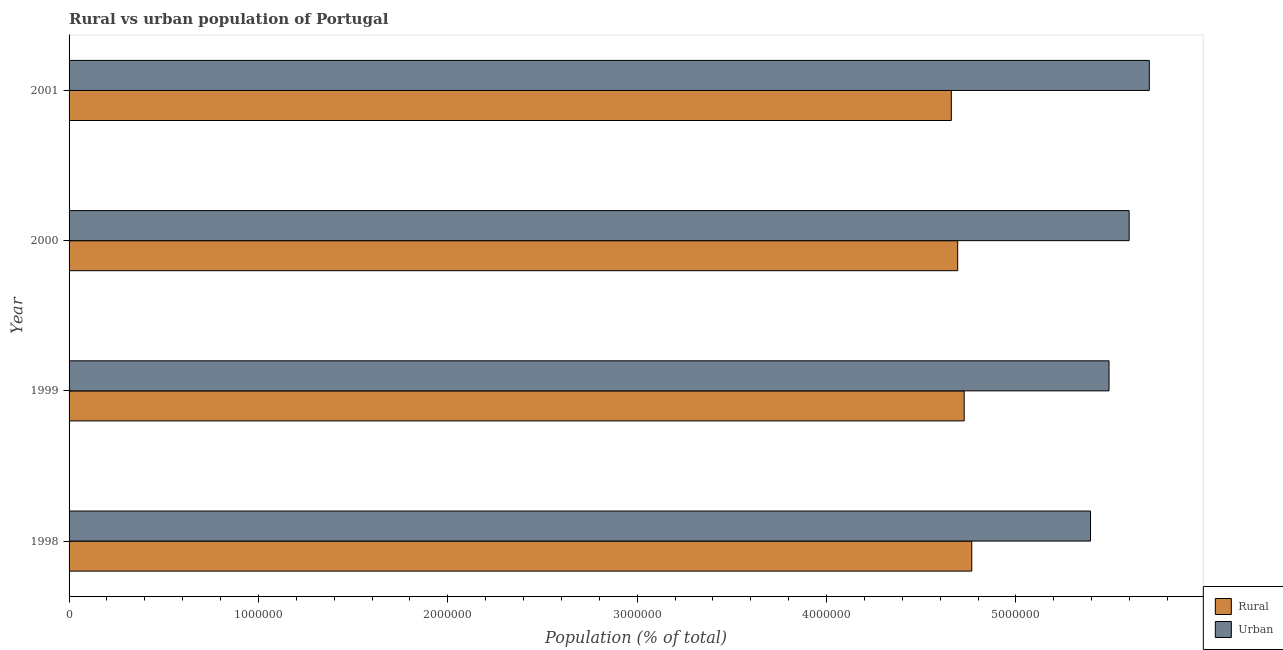How many different coloured bars are there?
Offer a terse response. 2. Are the number of bars per tick equal to the number of legend labels?
Provide a succinct answer. Yes. What is the urban population density in 1998?
Offer a very short reply. 5.39e+06. Across all years, what is the maximum rural population density?
Ensure brevity in your answer.  4.77e+06. Across all years, what is the minimum rural population density?
Provide a succinct answer. 4.66e+06. In which year was the urban population density maximum?
Make the answer very short. 2001. What is the total rural population density in the graph?
Give a very brief answer. 1.88e+07. What is the difference between the rural population density in 1999 and that in 2000?
Your response must be concise. 3.42e+04. What is the difference between the rural population density in 1998 and the urban population density in 2000?
Provide a short and direct response. -8.31e+05. What is the average rural population density per year?
Offer a very short reply. 4.71e+06. In the year 1999, what is the difference between the rural population density and urban population density?
Make the answer very short. -7.65e+05. What is the ratio of the urban population density in 2000 to that in 2001?
Provide a succinct answer. 0.98. What is the difference between the highest and the second highest rural population density?
Give a very brief answer. 4.01e+04. What is the difference between the highest and the lowest urban population density?
Your answer should be compact. 3.10e+05. In how many years, is the urban population density greater than the average urban population density taken over all years?
Your answer should be compact. 2. Is the sum of the rural population density in 2000 and 2001 greater than the maximum urban population density across all years?
Provide a succinct answer. Yes. What does the 1st bar from the top in 1998 represents?
Ensure brevity in your answer.  Urban. What does the 2nd bar from the bottom in 2000 represents?
Give a very brief answer. Urban. How many bars are there?
Make the answer very short. 8. What is the difference between two consecutive major ticks on the X-axis?
Ensure brevity in your answer.  1.00e+06. Are the values on the major ticks of X-axis written in scientific E-notation?
Make the answer very short. No. Does the graph contain any zero values?
Make the answer very short. No. Where does the legend appear in the graph?
Provide a short and direct response. Bottom right. What is the title of the graph?
Your response must be concise. Rural vs urban population of Portugal. Does "Formally registered" appear as one of the legend labels in the graph?
Keep it short and to the point. No. What is the label or title of the X-axis?
Provide a succinct answer. Population (% of total). What is the Population (% of total) in Rural in 1998?
Provide a succinct answer. 4.77e+06. What is the Population (% of total) in Urban in 1998?
Give a very brief answer. 5.39e+06. What is the Population (% of total) of Rural in 1999?
Make the answer very short. 4.73e+06. What is the Population (% of total) of Urban in 1999?
Ensure brevity in your answer.  5.49e+06. What is the Population (% of total) of Rural in 2000?
Provide a short and direct response. 4.69e+06. What is the Population (% of total) of Urban in 2000?
Your answer should be compact. 5.60e+06. What is the Population (% of total) of Rural in 2001?
Your response must be concise. 4.66e+06. What is the Population (% of total) in Urban in 2001?
Your answer should be compact. 5.70e+06. Across all years, what is the maximum Population (% of total) in Rural?
Your response must be concise. 4.77e+06. Across all years, what is the maximum Population (% of total) of Urban?
Your answer should be compact. 5.70e+06. Across all years, what is the minimum Population (% of total) in Rural?
Offer a terse response. 4.66e+06. Across all years, what is the minimum Population (% of total) in Urban?
Your response must be concise. 5.39e+06. What is the total Population (% of total) in Rural in the graph?
Give a very brief answer. 1.88e+07. What is the total Population (% of total) of Urban in the graph?
Offer a terse response. 2.22e+07. What is the difference between the Population (% of total) in Rural in 1998 and that in 1999?
Your answer should be very brief. 4.01e+04. What is the difference between the Population (% of total) in Urban in 1998 and that in 1999?
Provide a short and direct response. -9.77e+04. What is the difference between the Population (% of total) in Rural in 1998 and that in 2000?
Ensure brevity in your answer.  7.43e+04. What is the difference between the Population (% of total) in Urban in 1998 and that in 2000?
Your answer should be compact. -2.04e+05. What is the difference between the Population (% of total) in Rural in 1998 and that in 2001?
Ensure brevity in your answer.  1.08e+05. What is the difference between the Population (% of total) in Urban in 1998 and that in 2001?
Give a very brief answer. -3.10e+05. What is the difference between the Population (% of total) in Rural in 1999 and that in 2000?
Your response must be concise. 3.42e+04. What is the difference between the Population (% of total) in Urban in 1999 and that in 2000?
Provide a short and direct response. -1.06e+05. What is the difference between the Population (% of total) in Rural in 1999 and that in 2001?
Provide a succinct answer. 6.78e+04. What is the difference between the Population (% of total) of Urban in 1999 and that in 2001?
Ensure brevity in your answer.  -2.13e+05. What is the difference between the Population (% of total) in Rural in 2000 and that in 2001?
Offer a very short reply. 3.36e+04. What is the difference between the Population (% of total) of Urban in 2000 and that in 2001?
Offer a very short reply. -1.06e+05. What is the difference between the Population (% of total) in Rural in 1998 and the Population (% of total) in Urban in 1999?
Your answer should be compact. -7.25e+05. What is the difference between the Population (% of total) of Rural in 1998 and the Population (% of total) of Urban in 2000?
Provide a short and direct response. -8.31e+05. What is the difference between the Population (% of total) of Rural in 1998 and the Population (% of total) of Urban in 2001?
Offer a terse response. -9.38e+05. What is the difference between the Population (% of total) in Rural in 1999 and the Population (% of total) in Urban in 2000?
Keep it short and to the point. -8.71e+05. What is the difference between the Population (% of total) in Rural in 1999 and the Population (% of total) in Urban in 2001?
Your response must be concise. -9.78e+05. What is the difference between the Population (% of total) in Rural in 2000 and the Population (% of total) in Urban in 2001?
Make the answer very short. -1.01e+06. What is the average Population (% of total) of Rural per year?
Your answer should be compact. 4.71e+06. What is the average Population (% of total) in Urban per year?
Your answer should be very brief. 5.55e+06. In the year 1998, what is the difference between the Population (% of total) in Rural and Population (% of total) in Urban?
Give a very brief answer. -6.27e+05. In the year 1999, what is the difference between the Population (% of total) of Rural and Population (% of total) of Urban?
Ensure brevity in your answer.  -7.65e+05. In the year 2000, what is the difference between the Population (% of total) of Rural and Population (% of total) of Urban?
Your answer should be very brief. -9.05e+05. In the year 2001, what is the difference between the Population (% of total) of Rural and Population (% of total) of Urban?
Keep it short and to the point. -1.05e+06. What is the ratio of the Population (% of total) in Rural in 1998 to that in 1999?
Your answer should be very brief. 1.01. What is the ratio of the Population (% of total) of Urban in 1998 to that in 1999?
Offer a very short reply. 0.98. What is the ratio of the Population (% of total) of Rural in 1998 to that in 2000?
Your answer should be very brief. 1.02. What is the ratio of the Population (% of total) in Urban in 1998 to that in 2000?
Give a very brief answer. 0.96. What is the ratio of the Population (% of total) of Rural in 1998 to that in 2001?
Provide a succinct answer. 1.02. What is the ratio of the Population (% of total) of Urban in 1998 to that in 2001?
Provide a succinct answer. 0.95. What is the ratio of the Population (% of total) of Rural in 1999 to that in 2000?
Keep it short and to the point. 1.01. What is the ratio of the Population (% of total) of Rural in 1999 to that in 2001?
Your response must be concise. 1.01. What is the ratio of the Population (% of total) of Urban in 1999 to that in 2001?
Provide a succinct answer. 0.96. What is the ratio of the Population (% of total) in Rural in 2000 to that in 2001?
Your answer should be very brief. 1.01. What is the ratio of the Population (% of total) in Urban in 2000 to that in 2001?
Provide a succinct answer. 0.98. What is the difference between the highest and the second highest Population (% of total) in Rural?
Provide a short and direct response. 4.01e+04. What is the difference between the highest and the second highest Population (% of total) in Urban?
Your answer should be very brief. 1.06e+05. What is the difference between the highest and the lowest Population (% of total) of Rural?
Offer a terse response. 1.08e+05. What is the difference between the highest and the lowest Population (% of total) in Urban?
Offer a terse response. 3.10e+05. 